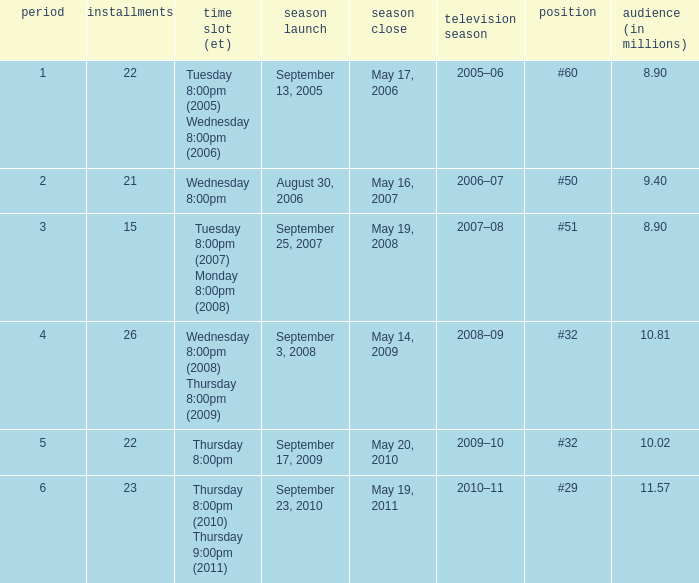What tv season was episode 23 broadcast? 2010–11. 